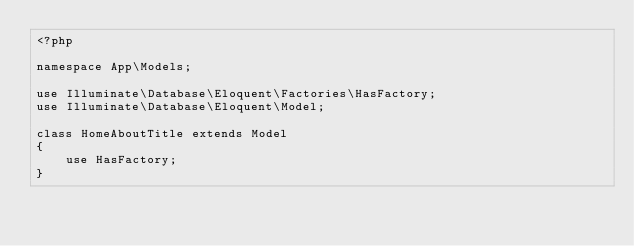Convert code to text. <code><loc_0><loc_0><loc_500><loc_500><_PHP_><?php

namespace App\Models;

use Illuminate\Database\Eloquent\Factories\HasFactory;
use Illuminate\Database\Eloquent\Model;

class HomeAboutTitle extends Model
{
    use HasFactory;
}
</code> 